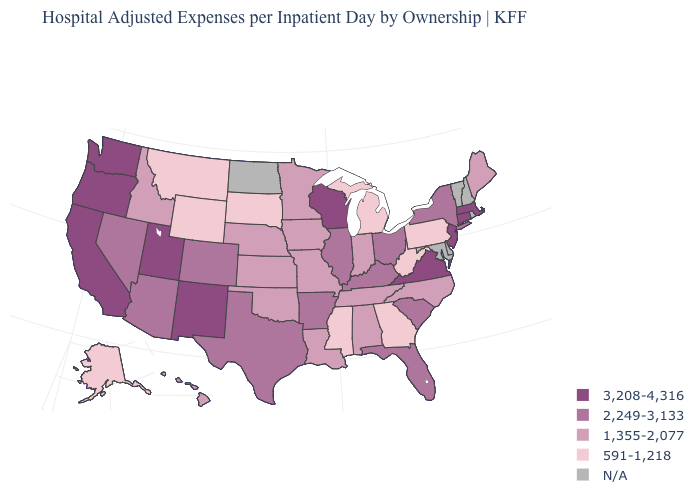What is the value of Minnesota?
Answer briefly. 1,355-2,077. Name the states that have a value in the range N/A?
Concise answer only. Delaware, Maryland, New Hampshire, North Dakota, Rhode Island, Vermont. What is the value of Maine?
Short answer required. 1,355-2,077. Which states have the highest value in the USA?
Concise answer only. California, Connecticut, Massachusetts, New Jersey, New Mexico, Oregon, Utah, Virginia, Washington, Wisconsin. What is the value of Tennessee?
Keep it brief. 1,355-2,077. What is the value of Virginia?
Quick response, please. 3,208-4,316. Does Pennsylvania have the lowest value in the USA?
Be succinct. Yes. Name the states that have a value in the range 2,249-3,133?
Short answer required. Arizona, Arkansas, Colorado, Florida, Illinois, Kentucky, Nevada, New York, Ohio, South Carolina, Texas. Name the states that have a value in the range N/A?
Quick response, please. Delaware, Maryland, New Hampshire, North Dakota, Rhode Island, Vermont. Among the states that border Oregon , which have the highest value?
Answer briefly. California, Washington. Does the first symbol in the legend represent the smallest category?
Answer briefly. No. What is the lowest value in the USA?
Write a very short answer. 591-1,218. Among the states that border New Mexico , does Arizona have the lowest value?
Answer briefly. No. Name the states that have a value in the range 591-1,218?
Concise answer only. Alaska, Georgia, Michigan, Mississippi, Montana, Pennsylvania, South Dakota, West Virginia, Wyoming. 